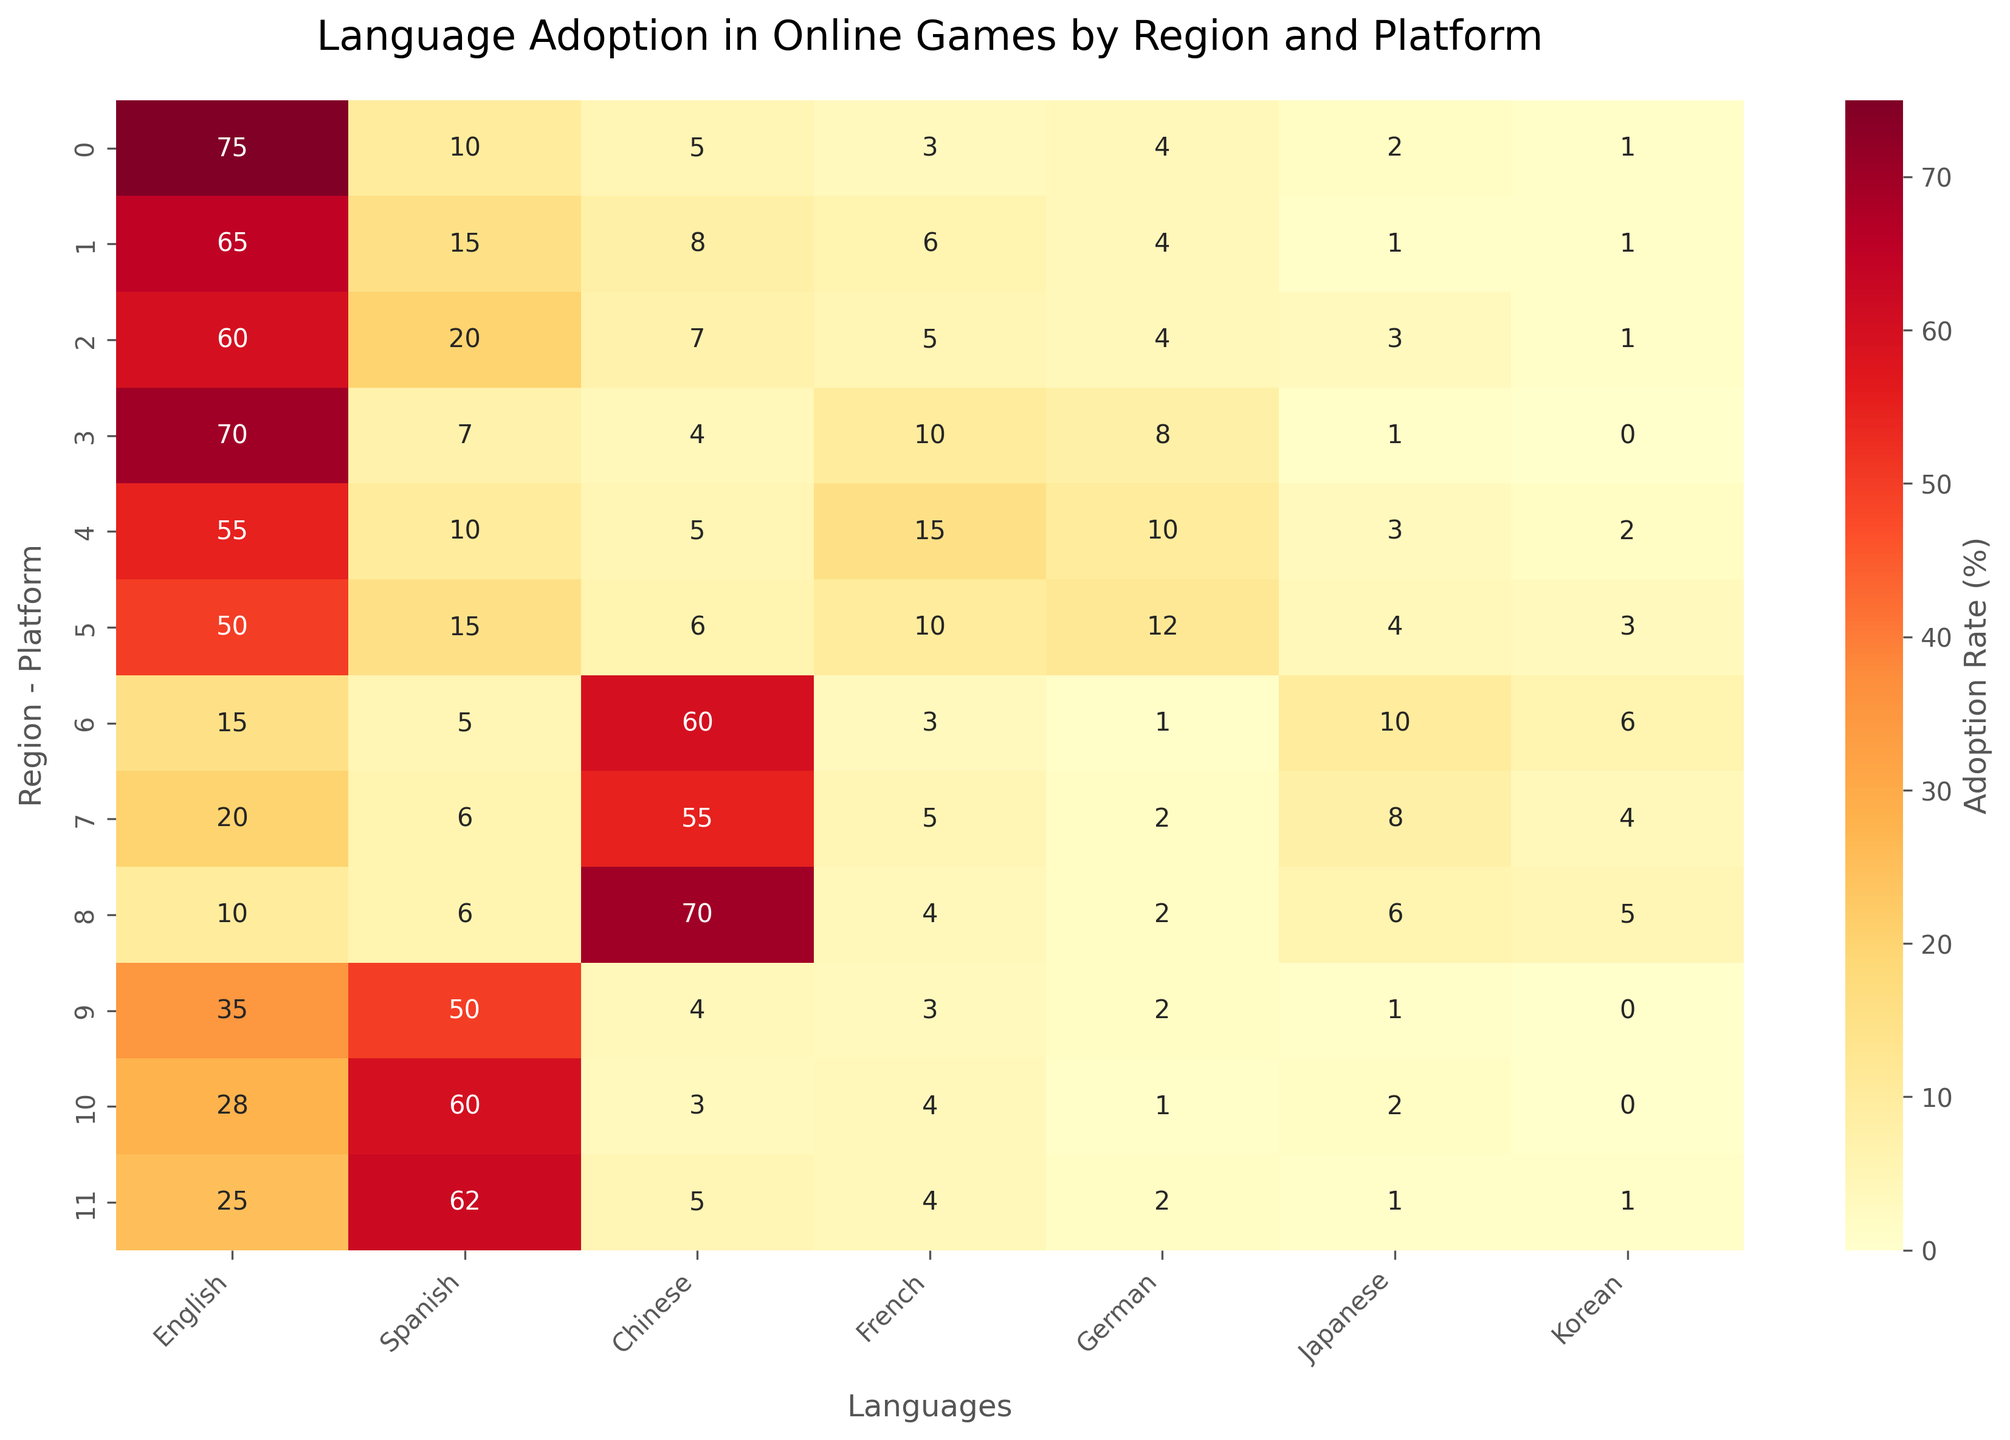What are the language options displayed on the x-axis? The x-axis of the heatmap represents the available languages. Visually, these languages are labeled as English, Spanish, Chinese, French, German, Japanese, and Korean
Answer: English, Spanish, Chinese, French, German, Japanese, Korean Which region-platform combination has the highest adoption of the Chinese language? To find this, we examine the Chinese language column for the highest value across all region-platform rows. The highest number in the Chinese column is 70 for Asia-Mobile.
Answer: Asia-Mobile How does English language adoption on PC compare between North America and Europe? Locate the English adoption rates for PC in both North America and Europe. North America has 75, and Europe has 70. Compare these values to determine which is higher.
Answer: North America has higher adoption (75 vs. 70) What is the average adoption rate of Japanese across all platforms in Asia? Identify the Japanese adoption rates in Asia across all platforms: PC (10), Console (8), and Mobile (6). Calculate the average of these values: (10 + 8 + 6) / 3 = 24 / 3 = 8.
Answer: 8 Which platform in South America has the highest Spanish language adoption rate? Within the Spanish column for South America, compare the adoption rates across PC, Console, and Mobile, which are 50, 60, and 62, respectively. The highest adoption rate is 62 for Mobile.
Answer: Mobile Does Europe have higher German adoption rates on Consoles or Mobile platforms? Check the German adoption rates for Europe in Console and Mobile: Console (10) and Mobile (12). Compare these values to determine the higher rate.
Answer: Mobile What can you say about the overall adoption trends of Korean language in North America? Explore the Korean adoption rates in North America across PC, Console, and Mobile: PC (1), Console (1), Mobile (1). All rates are the same, showing consistent minimal adoption.
Answer: Minimal and consistent Summarize the adoption of the French language in all regions' PC platforms. Identify the adoption rates of French on PCs in each region: North America (3), Europe (10), Asia (3), South America (3). Sum these values: 3 + 10 + 3 + 3 = 19.
Answer: Summed adoption is 19 Rank the platforms in Asia by their Chinese language adoption rates, from highest to lowest. Observe the Chinese adoption rates for the three Asian platforms PC (60), Console (55), and Mobile (70). Arrange these in descending order: Mobile (70), PC (60), Console (55).
Answer: Mobile, PC, Console What trend do you observe in English language adoption across platforms in Europe? Analyze the English adoption rates across all European platforms: PC (70), Console (55), Mobile (50). The trend shows decreasing adoption moving from PC to Console to Mobile.
Answer: Decreasing from PC to Mobile 